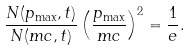<formula> <loc_0><loc_0><loc_500><loc_500>\frac { N ( p _ { \max } , t ) } { N ( m c , t ) } \left ( \frac { p _ { \max } } { m c } \right ) ^ { 2 } = \frac { 1 } { e } .</formula> 